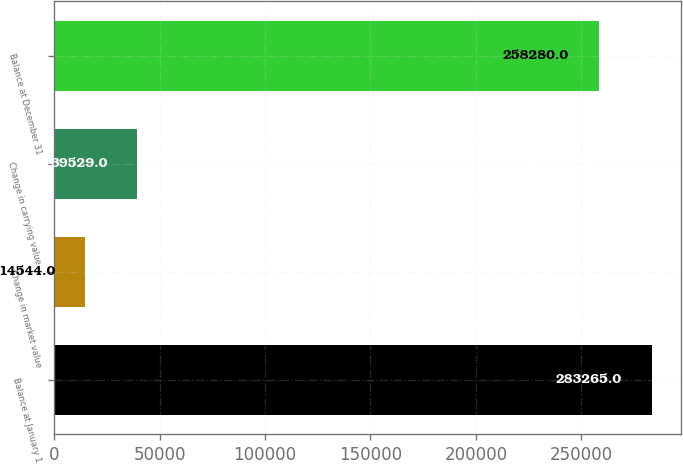Convert chart to OTSL. <chart><loc_0><loc_0><loc_500><loc_500><bar_chart><fcel>Balance at January 1<fcel>Change in market value<fcel>Change in carrying value<fcel>Balance at December 31<nl><fcel>283265<fcel>14544<fcel>39529<fcel>258280<nl></chart> 